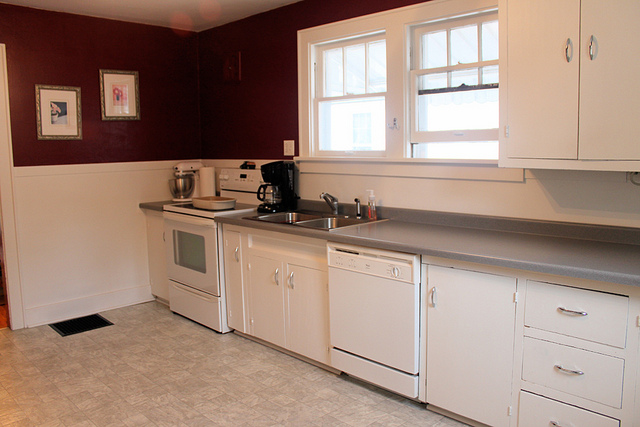Does the kitchen have a dishwasher? Yes, there is a dishwasher located to the right of the sink, adding convenience for dishwashing. 